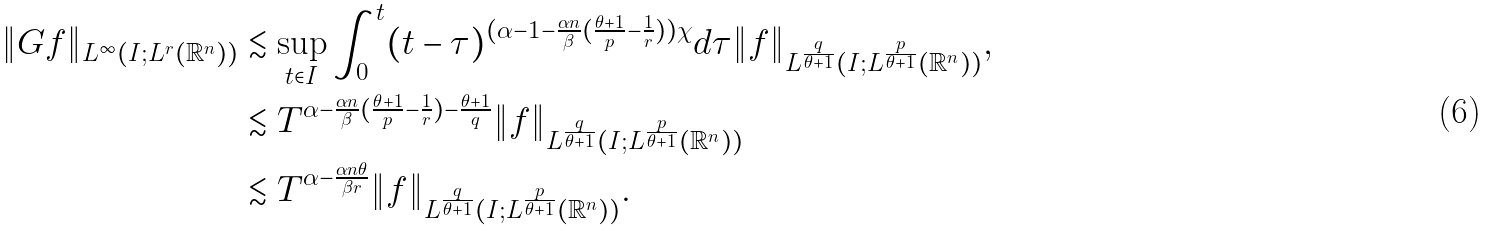<formula> <loc_0><loc_0><loc_500><loc_500>\| G f \| _ { L ^ { \infty } ( I ; L ^ { r } ( \mathbb { R } ^ { n } ) ) } & \lesssim \sup _ { t \in I } \int _ { 0 } ^ { t } ( t - \tau ) ^ { ( \alpha - 1 - \frac { \alpha n } { \beta } ( \frac { \theta + 1 } { p } - \frac { 1 } { r } ) ) \chi } d \tau \| f \| _ { L ^ { \frac { q } { \theta + 1 } } ( I ; L ^ { \frac { p } { \theta + 1 } } ( \mathbb { R } ^ { n } ) ) } , \\ & \lesssim T ^ { \alpha - \frac { \alpha n } { \beta } ( \frac { \theta + 1 } { p } - \frac { 1 } { r } ) - \frac { \theta + 1 } { q } } \| f \| _ { L ^ { \frac { q } { \theta + 1 } } ( I ; L ^ { \frac { p } { \theta + 1 } } ( \mathbb { R } ^ { n } ) ) } \\ & \lesssim T ^ { \alpha - \frac { \alpha n \theta } { \beta r } } \| f \| _ { L ^ { \frac { q } { \theta + 1 } } ( I ; L ^ { \frac { p } { \theta + 1 } } ( \mathbb { R } ^ { n } ) ) } .</formula> 